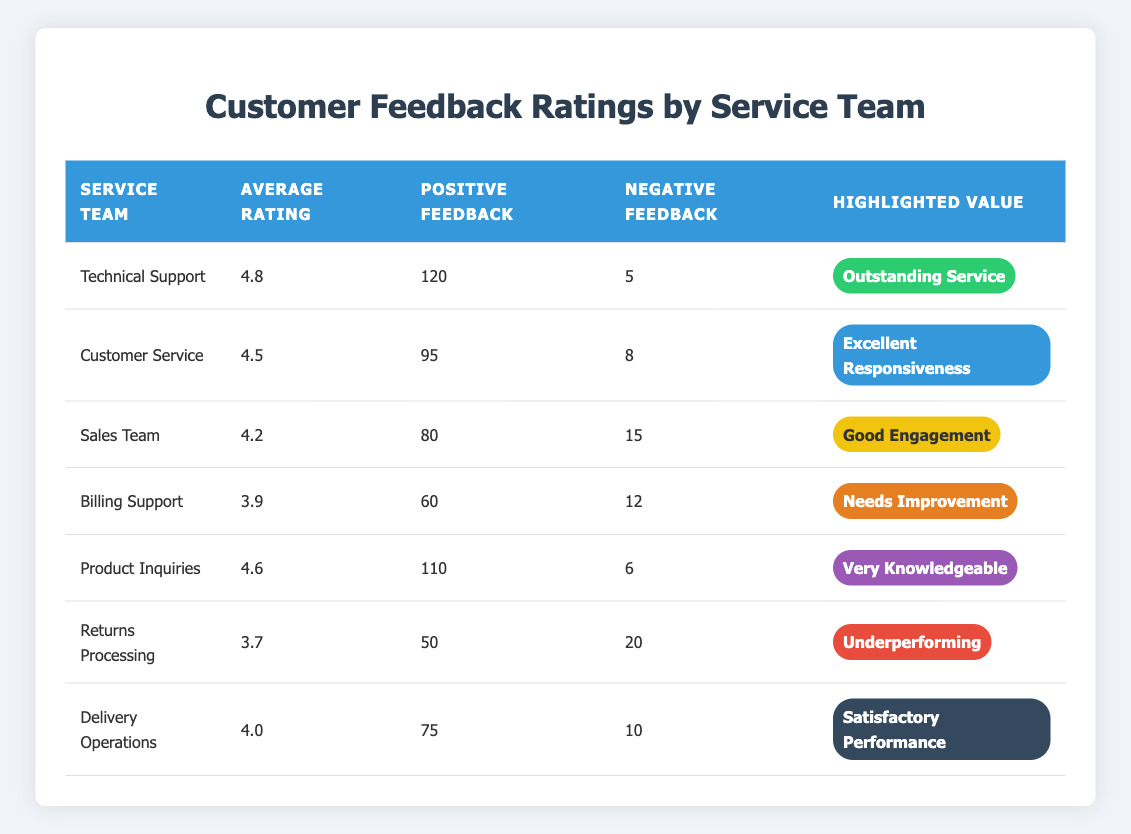What is the Average Rating of the Technical Support team? In the table, the Average Rating for the Technical Support team is directly listed as 4.8.
Answer: 4.8 How many Positive Feedbacks did the Returns Processing team receive? The Positive Feedback Count for the Returns Processing team is shown as 50 in the table.
Answer: 50 Which service team received the highest number of Negative Feedbacks? The Returns Processing team has the highest Negative Feedback Count of 20, as seen in the table.
Answer: Returns Processing What is the difference between the Average Ratings of Sales Team and Delivery Operations? The Average Rating for Sales Team is 4.2 and for Delivery Operations is 4.0. The difference is 4.2 - 4.0 = 0.2.
Answer: 0.2 Which team has been highlighted as "Needs Improvement"? The Billing Support team is highlighted with "Needs Improvement" in the table.
Answer: Billing Support Is it true that the Customer Service team has more Positive Feedback than the Sales Team? The Customer Service team has 95 Positive Feedbacks, while the Sales Team has 80. Since 95 is greater than 80, the statement is true.
Answer: True What is the average Positive Feedback Count for teams with an Average Rating above 4.0? The teams with an Average Rating above 4.0 are Technical Support (120), Customer Service (95), Sales Team (80), Product Inquiries (110), and Delivery Operations (75). Their total is 120 + 95 + 80 + 110 + 75 = 480. There are 5 such teams, so the average is 480 / 5 = 96.
Answer: 96 How many teams have an Average Rating below 4.0? The teams with an Average Rating below 4.0 are Billing Support (3.9) and Returns Processing (3.7), totaling 2 teams.
Answer: 2 Which service team has the highest Average Rating, and what is that rating? The Technical Support team has the highest Average Rating of 4.8 according to the table.
Answer: Technical Support, 4.8 What percentage of feedback for the Product Inquiries team was positive? The Product Inquiries team has 110 Positive Feedbacks out of a total of 110 + 6 = 116 feedbacks, resulting in (110 / 116) * 100 ≈ 94.83%.
Answer: Approximately 94.83% Which service team shows "Satisfactory Performance" in terms of their feedback? The team highlighted with "Satisfactory Performance" is the Delivery Operations team, as indicated in the table.
Answer: Delivery Operations 